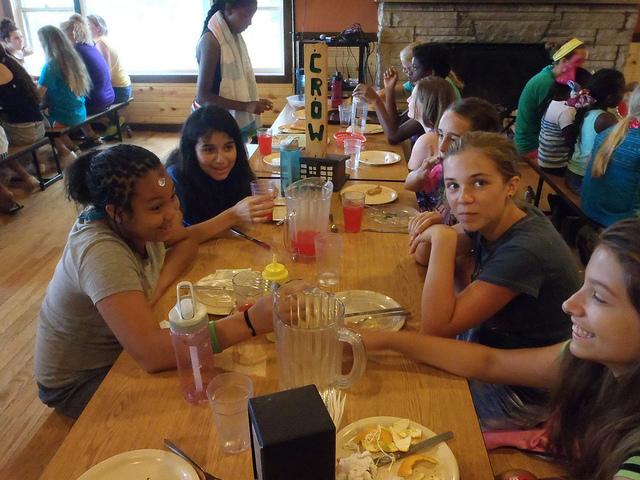How many people are wearing yellow?
Write a very short answer. 1. Is there napkins in the napkin holder?
Keep it brief. Yes. How many pitchers are visible?
Answer briefly. 2. What color is the liquid?
Quick response, please. Red. 